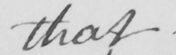Transcribe the text shown in this historical manuscript line. that 